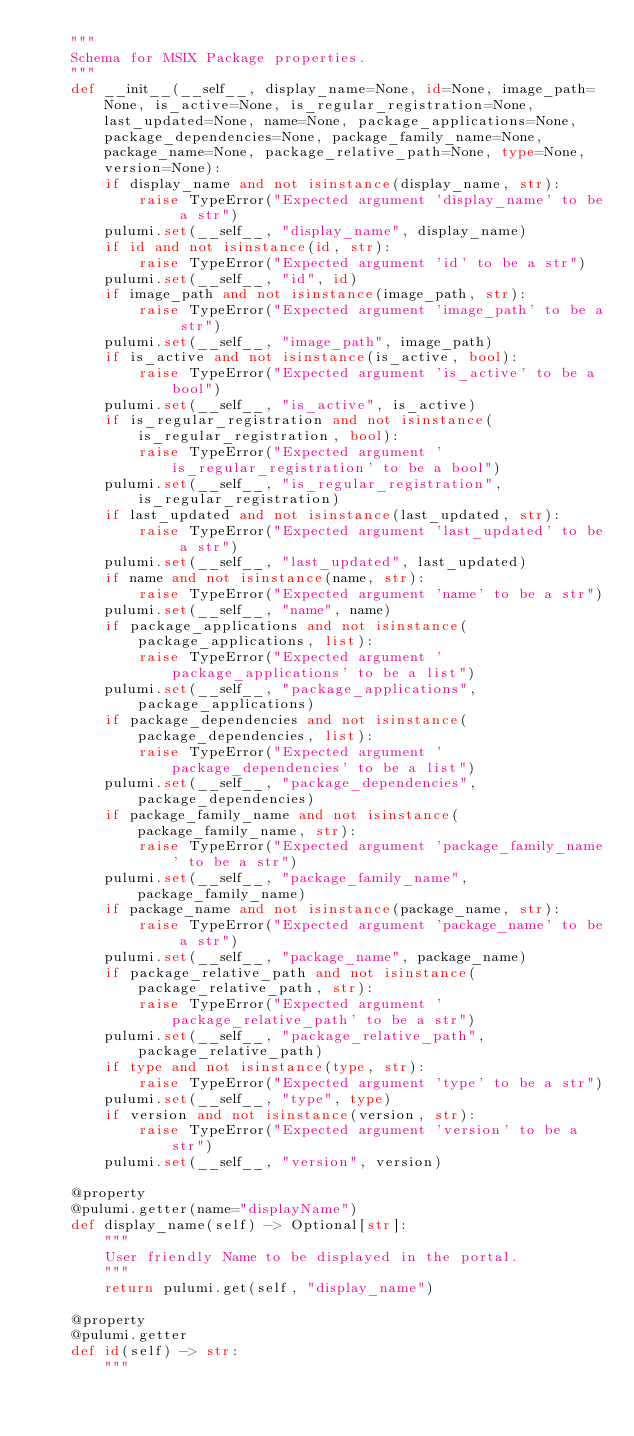<code> <loc_0><loc_0><loc_500><loc_500><_Python_>    """
    Schema for MSIX Package properties.
    """
    def __init__(__self__, display_name=None, id=None, image_path=None, is_active=None, is_regular_registration=None, last_updated=None, name=None, package_applications=None, package_dependencies=None, package_family_name=None, package_name=None, package_relative_path=None, type=None, version=None):
        if display_name and not isinstance(display_name, str):
            raise TypeError("Expected argument 'display_name' to be a str")
        pulumi.set(__self__, "display_name", display_name)
        if id and not isinstance(id, str):
            raise TypeError("Expected argument 'id' to be a str")
        pulumi.set(__self__, "id", id)
        if image_path and not isinstance(image_path, str):
            raise TypeError("Expected argument 'image_path' to be a str")
        pulumi.set(__self__, "image_path", image_path)
        if is_active and not isinstance(is_active, bool):
            raise TypeError("Expected argument 'is_active' to be a bool")
        pulumi.set(__self__, "is_active", is_active)
        if is_regular_registration and not isinstance(is_regular_registration, bool):
            raise TypeError("Expected argument 'is_regular_registration' to be a bool")
        pulumi.set(__self__, "is_regular_registration", is_regular_registration)
        if last_updated and not isinstance(last_updated, str):
            raise TypeError("Expected argument 'last_updated' to be a str")
        pulumi.set(__self__, "last_updated", last_updated)
        if name and not isinstance(name, str):
            raise TypeError("Expected argument 'name' to be a str")
        pulumi.set(__self__, "name", name)
        if package_applications and not isinstance(package_applications, list):
            raise TypeError("Expected argument 'package_applications' to be a list")
        pulumi.set(__self__, "package_applications", package_applications)
        if package_dependencies and not isinstance(package_dependencies, list):
            raise TypeError("Expected argument 'package_dependencies' to be a list")
        pulumi.set(__self__, "package_dependencies", package_dependencies)
        if package_family_name and not isinstance(package_family_name, str):
            raise TypeError("Expected argument 'package_family_name' to be a str")
        pulumi.set(__self__, "package_family_name", package_family_name)
        if package_name and not isinstance(package_name, str):
            raise TypeError("Expected argument 'package_name' to be a str")
        pulumi.set(__self__, "package_name", package_name)
        if package_relative_path and not isinstance(package_relative_path, str):
            raise TypeError("Expected argument 'package_relative_path' to be a str")
        pulumi.set(__self__, "package_relative_path", package_relative_path)
        if type and not isinstance(type, str):
            raise TypeError("Expected argument 'type' to be a str")
        pulumi.set(__self__, "type", type)
        if version and not isinstance(version, str):
            raise TypeError("Expected argument 'version' to be a str")
        pulumi.set(__self__, "version", version)

    @property
    @pulumi.getter(name="displayName")
    def display_name(self) -> Optional[str]:
        """
        User friendly Name to be displayed in the portal. 
        """
        return pulumi.get(self, "display_name")

    @property
    @pulumi.getter
    def id(self) -> str:
        """</code> 